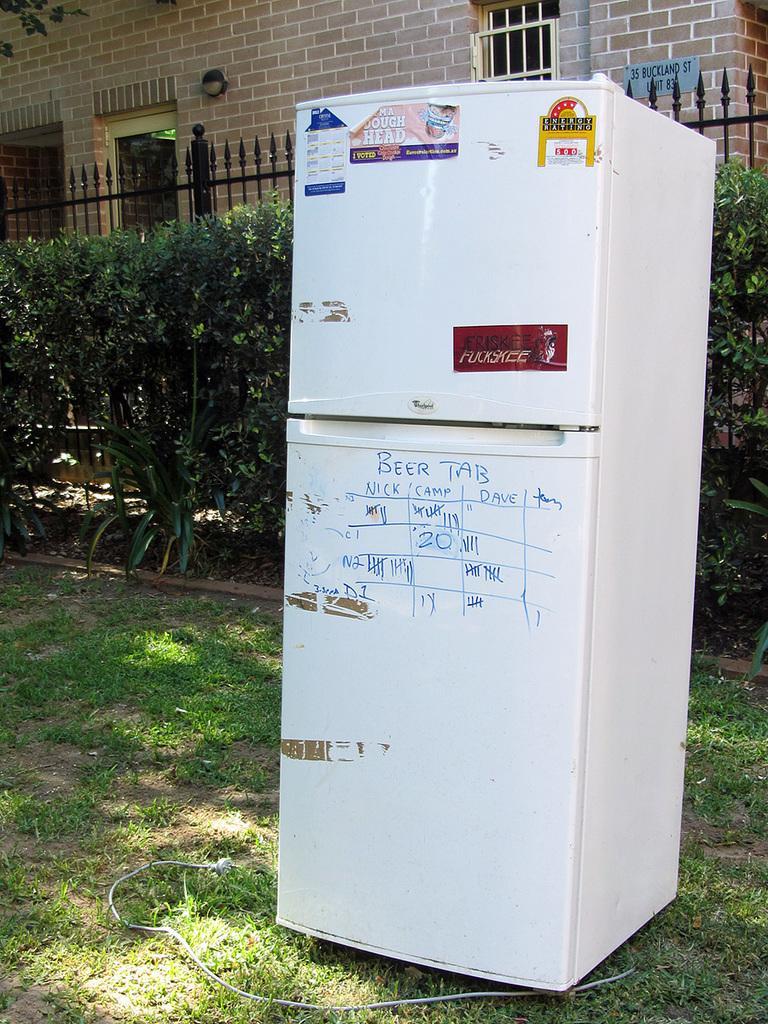How would you summarize this image in a sentence or two? In this we can see a white color fridge, behind plants fencing and wall is there. And on land some grass is present. 